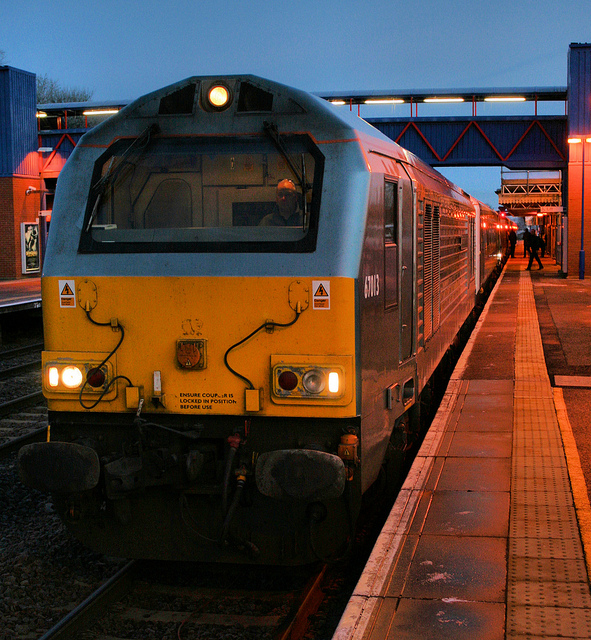<image>What side of the train are the people sitting? It is ambiguous to determine what side of the train the people are sitting. It could be either the left or the right side. What side of the train are the people sitting? I don't know what side of the train are the people sitting. It can be either the left side or the right side. 